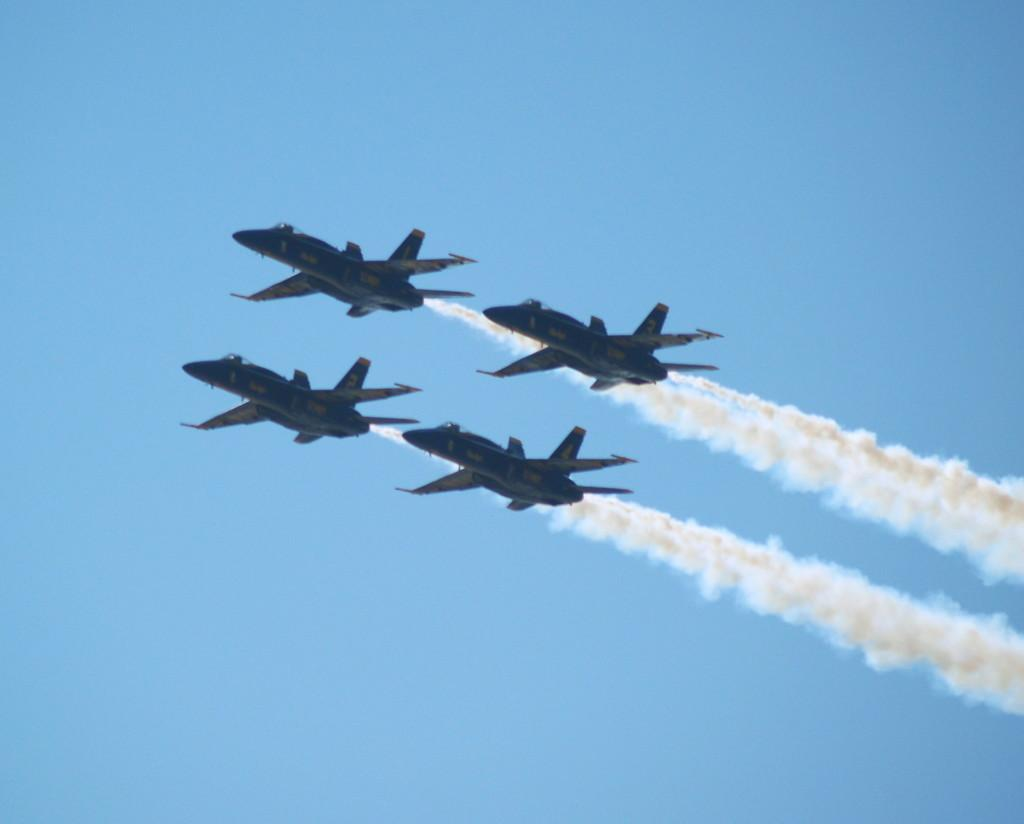How many jet planes are visible in the image? There are four jet planes in the image. What are the jet planes doing in the image? The jet planes are flying in the sky. What can be seen coming from the jet planes? There is smoke released by the jet planes. What is the color of the sky in the image? The sky is blue in color. What type of stage can be seen in the image? There is no stage present in the image; it features four jet planes flying in the sky. What hobbies do the jet planes have in the image? Jet planes do not have hobbies, as they are inanimate objects. 